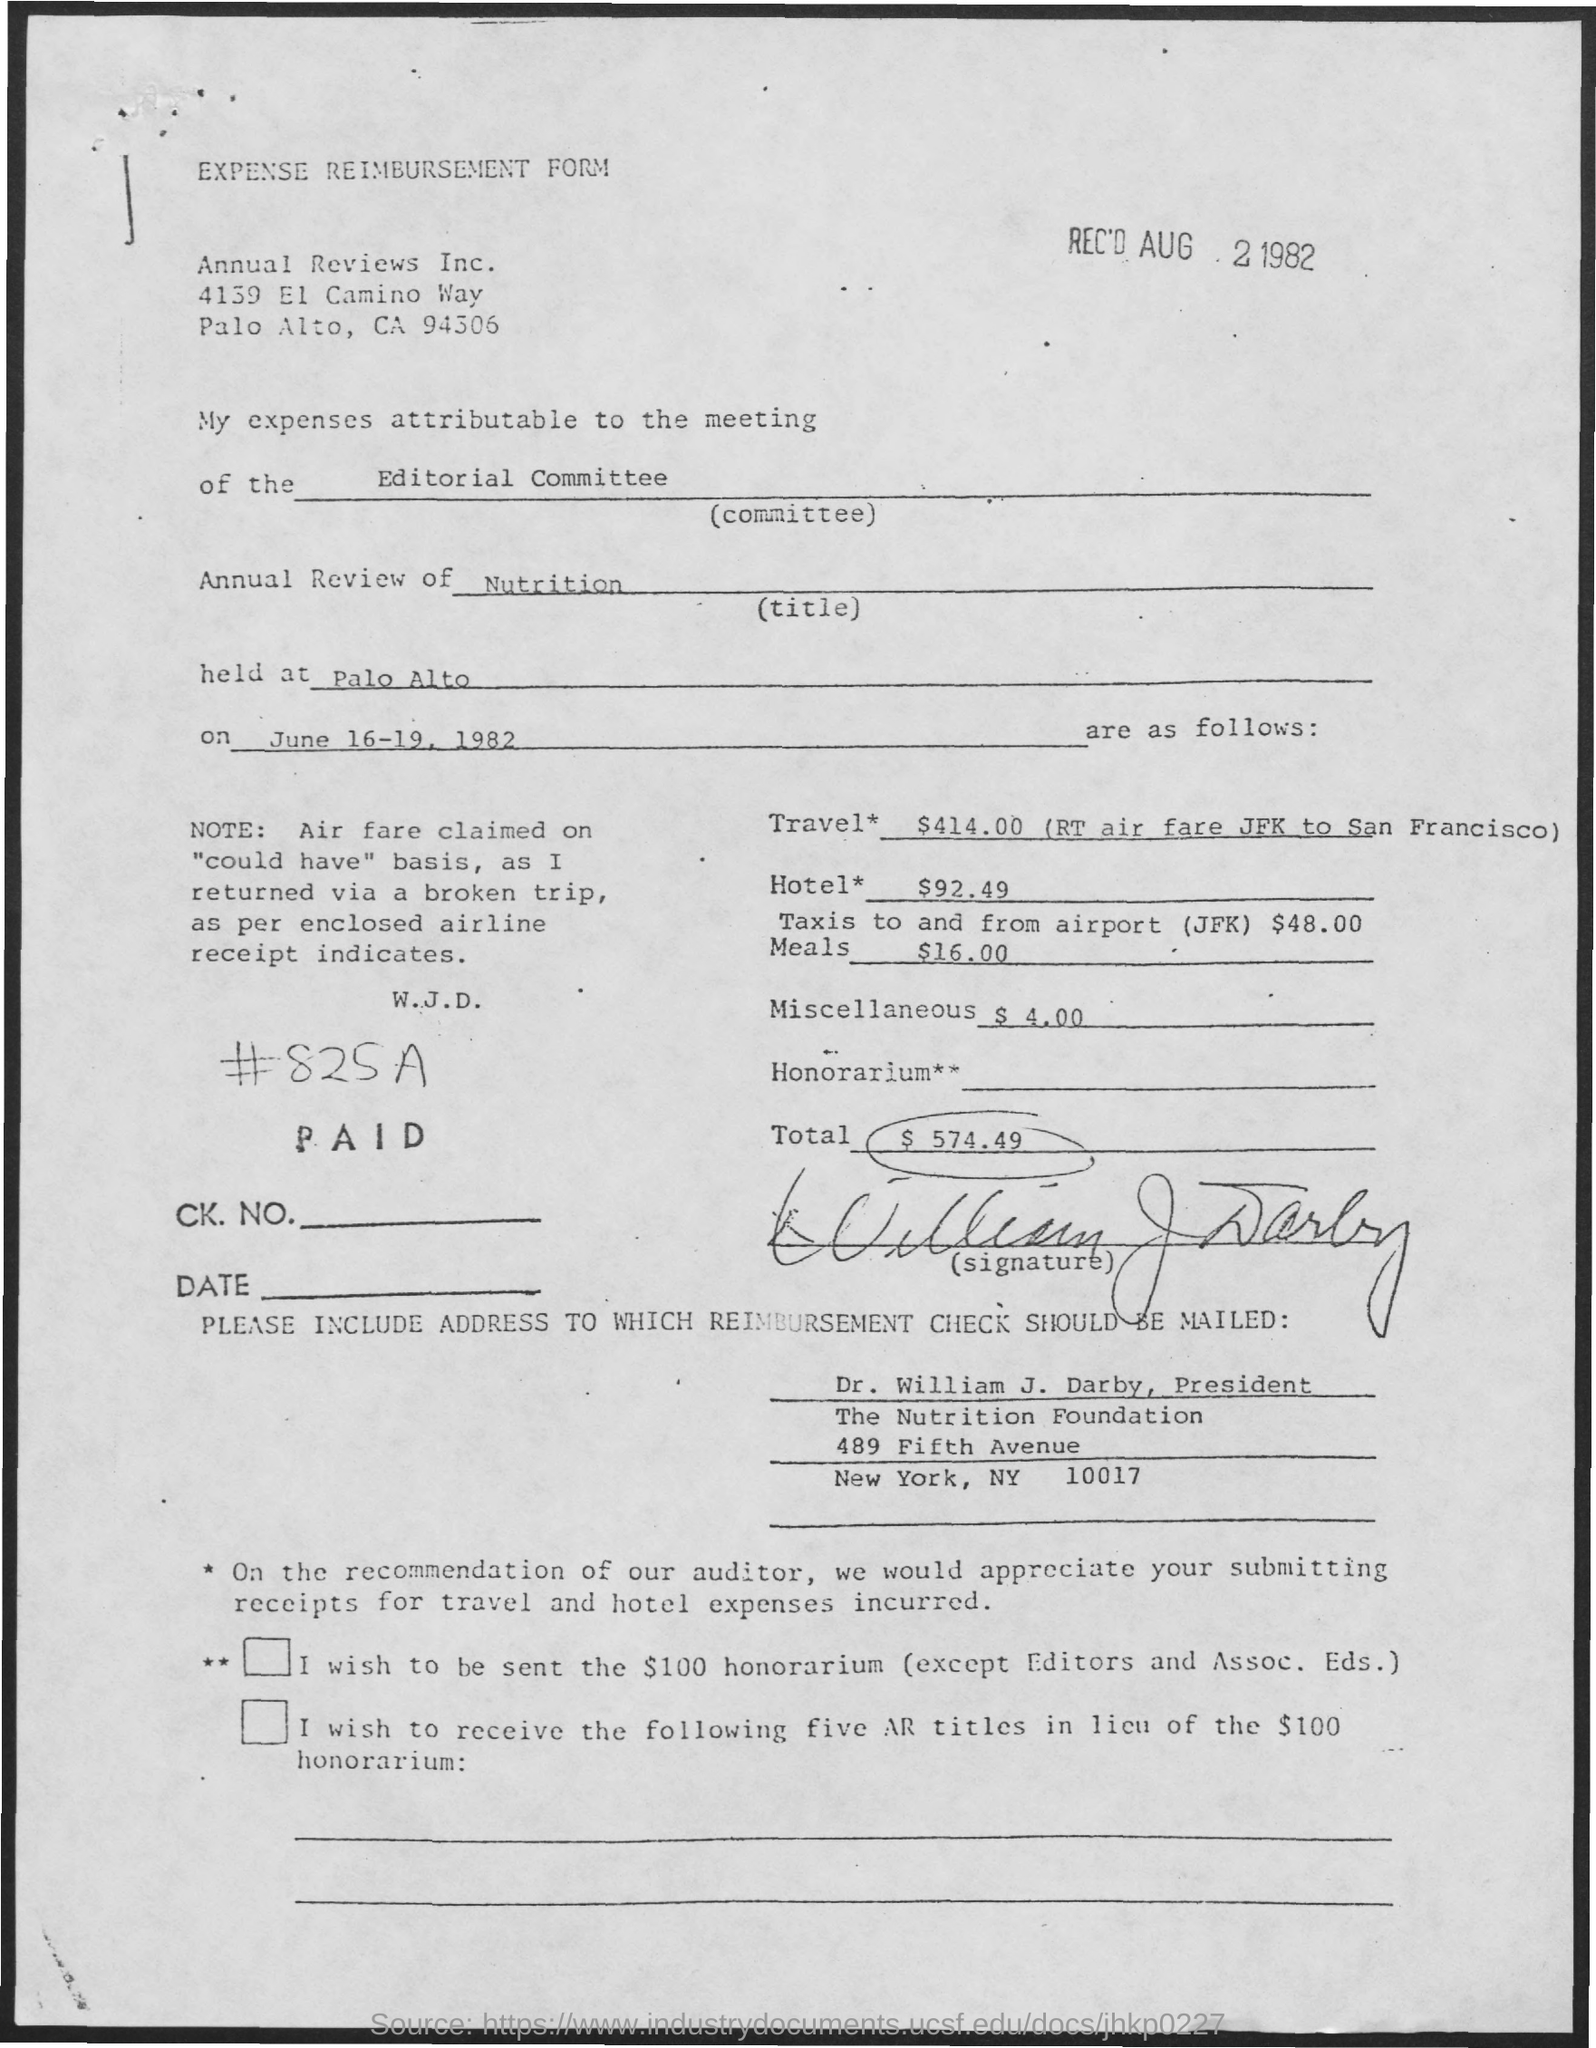List a handful of essential elements in this visual. The meetings were conducted on the dates of June 16-19, 1982. The form was received on August 2, 1982. The given form mentions a committee named "editorial committee. The meeting was held in Palo Alto. The form is named "Expense Reimbursement Form. 